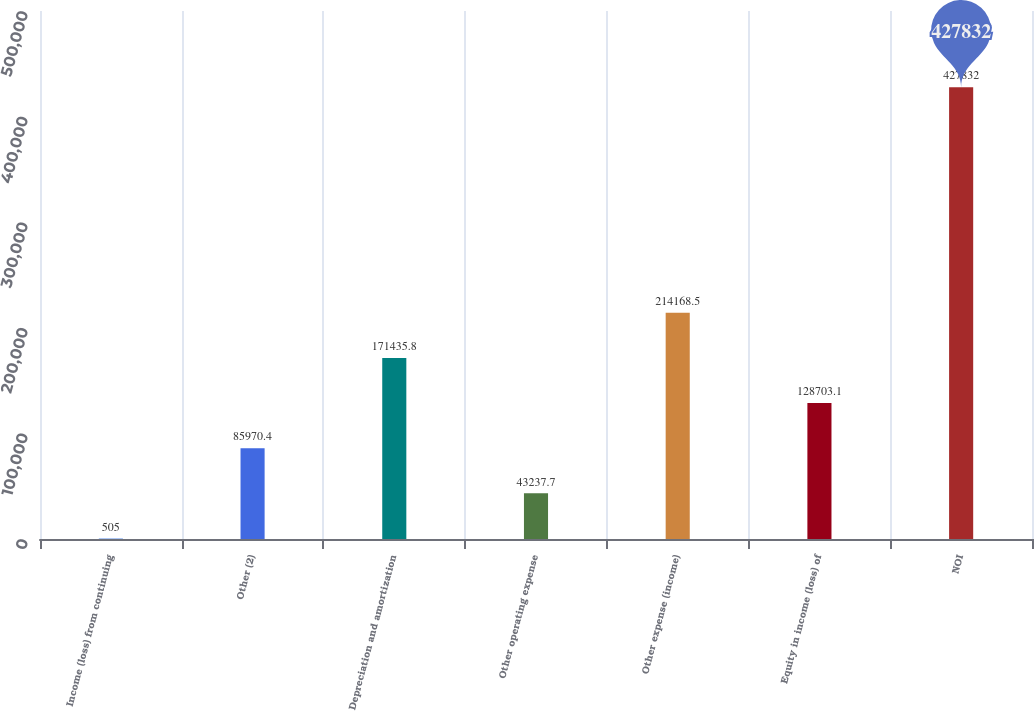Convert chart. <chart><loc_0><loc_0><loc_500><loc_500><bar_chart><fcel>Income (loss) from continuing<fcel>Other (2)<fcel>Depreciation and amortization<fcel>Other operating expense<fcel>Other expense (income)<fcel>Equity in income (loss) of<fcel>NOI<nl><fcel>505<fcel>85970.4<fcel>171436<fcel>43237.7<fcel>214168<fcel>128703<fcel>427832<nl></chart> 